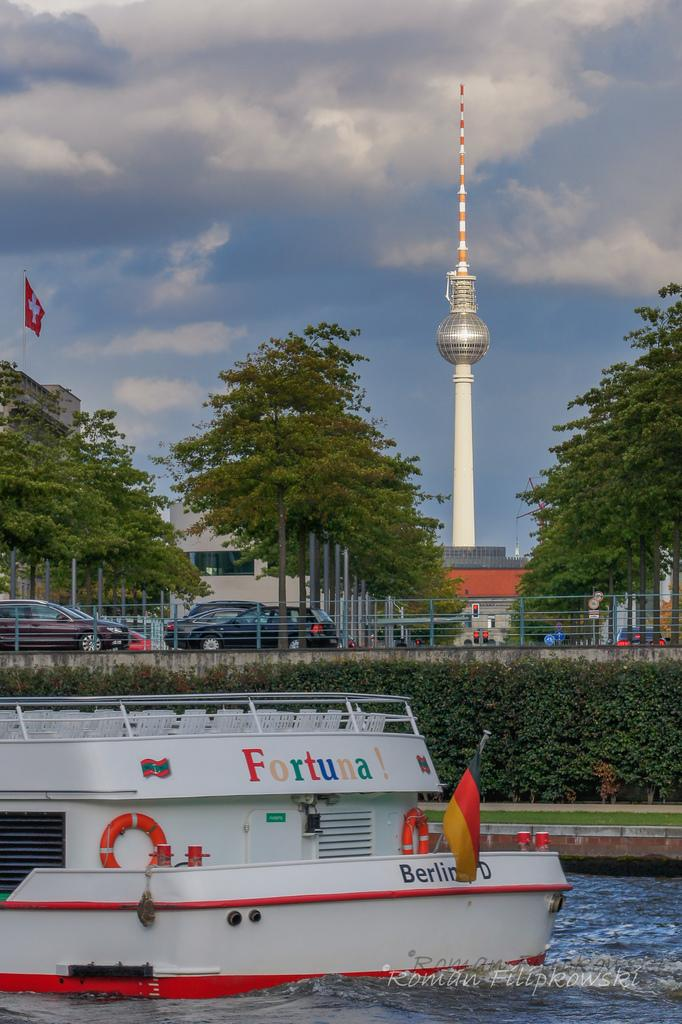<image>
Give a short and clear explanation of the subsequent image. The back of a white boat identifies the boat's name as Fortuna! 